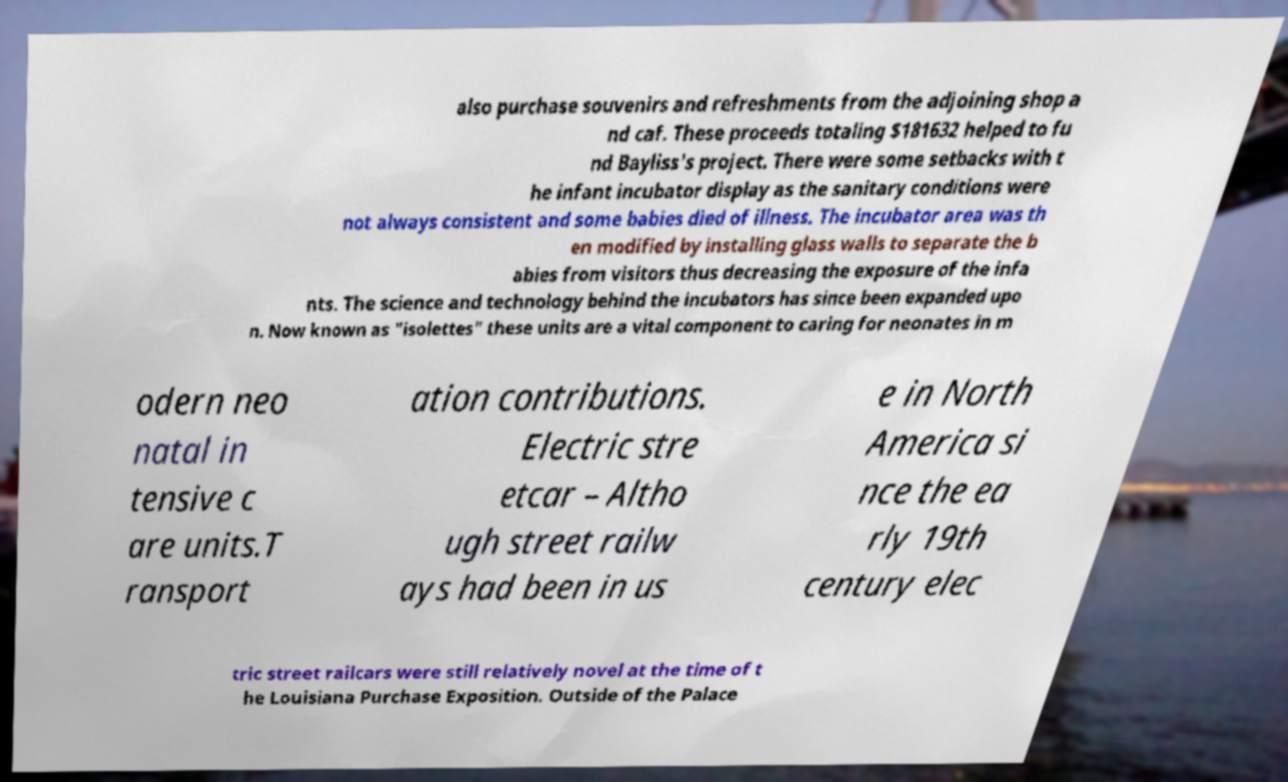Please identify and transcribe the text found in this image. also purchase souvenirs and refreshments from the adjoining shop a nd caf. These proceeds totaling $181632 helped to fu nd Bayliss's project. There were some setbacks with t he infant incubator display as the sanitary conditions were not always consistent and some babies died of illness. The incubator area was th en modified by installing glass walls to separate the b abies from visitors thus decreasing the exposure of the infa nts. The science and technology behind the incubators has since been expanded upo n. Now known as "isolettes" these units are a vital component to caring for neonates in m odern neo natal in tensive c are units.T ransport ation contributions. Electric stre etcar – Altho ugh street railw ays had been in us e in North America si nce the ea rly 19th century elec tric street railcars were still relatively novel at the time of t he Louisiana Purchase Exposition. Outside of the Palace 